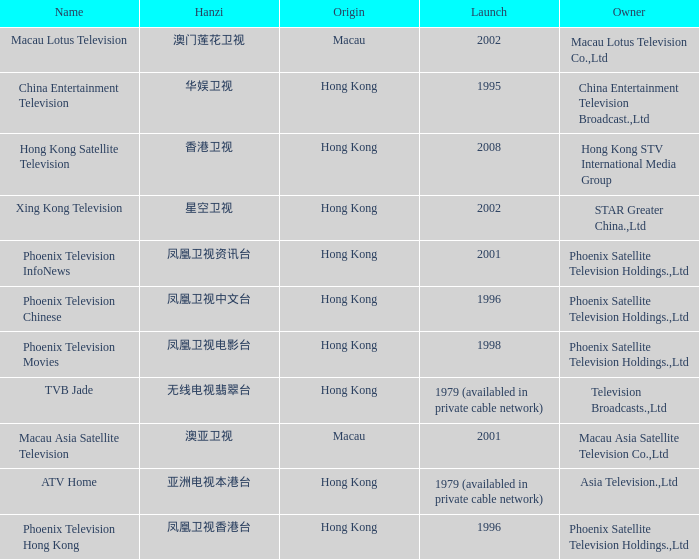Which company launched in 1996 and has a Hanzi of 凤凰卫视中文台? Phoenix Television Chinese. 